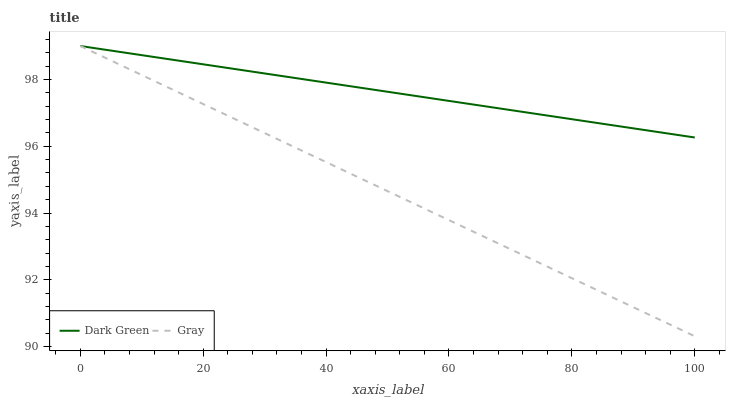Does Gray have the minimum area under the curve?
Answer yes or no. Yes. Does Dark Green have the maximum area under the curve?
Answer yes or no. Yes. Does Dark Green have the minimum area under the curve?
Answer yes or no. No. Is Dark Green the smoothest?
Answer yes or no. Yes. Is Gray the roughest?
Answer yes or no. Yes. Is Dark Green the roughest?
Answer yes or no. No. Does Gray have the lowest value?
Answer yes or no. Yes. Does Dark Green have the lowest value?
Answer yes or no. No. Does Dark Green have the highest value?
Answer yes or no. Yes. Does Dark Green intersect Gray?
Answer yes or no. Yes. Is Dark Green less than Gray?
Answer yes or no. No. Is Dark Green greater than Gray?
Answer yes or no. No. 